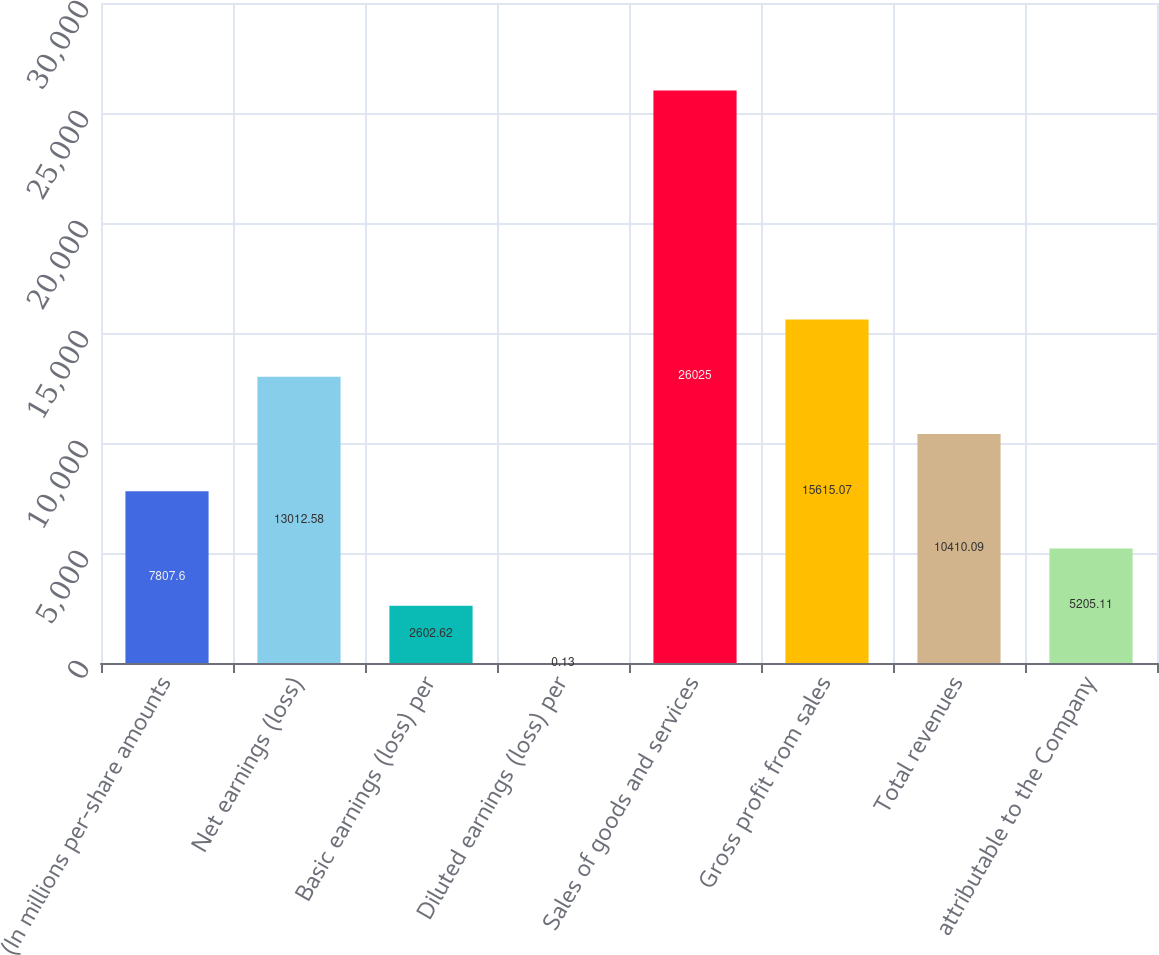<chart> <loc_0><loc_0><loc_500><loc_500><bar_chart><fcel>(In millions per-share amounts<fcel>Net earnings (loss)<fcel>Basic earnings (loss) per<fcel>Diluted earnings (loss) per<fcel>Sales of goods and services<fcel>Gross profit from sales<fcel>Total revenues<fcel>attributable to the Company<nl><fcel>7807.6<fcel>13012.6<fcel>2602.62<fcel>0.13<fcel>26025<fcel>15615.1<fcel>10410.1<fcel>5205.11<nl></chart> 